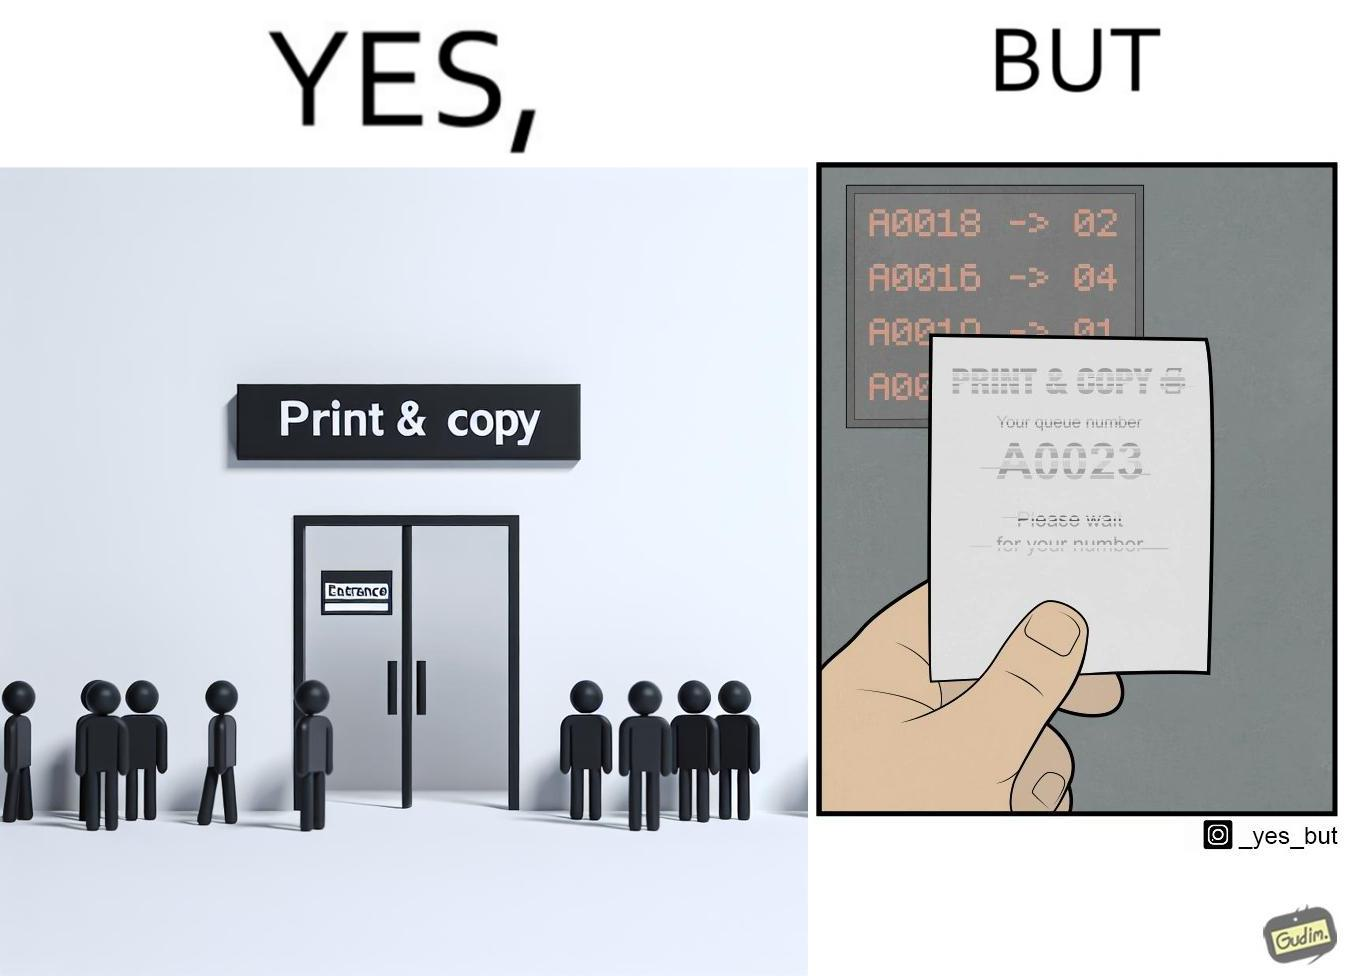Explain why this image is satirical. The image is ironic, as the waiting slip in a "Print & Copy" Centre is printed with insufficient printing ink. 